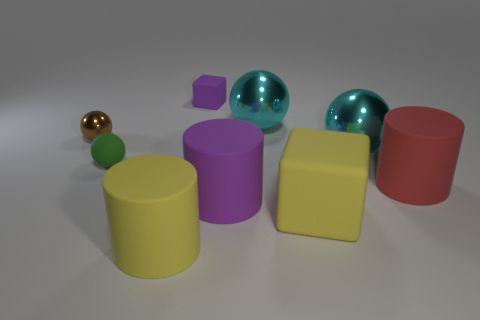Add 1 large blue cubes. How many objects exist? 10 Subtract all balls. How many objects are left? 5 Add 8 tiny green balls. How many tiny green balls are left? 9 Add 9 purple shiny spheres. How many purple shiny spheres exist? 9 Subtract 0 gray cylinders. How many objects are left? 9 Subtract all red cylinders. Subtract all rubber blocks. How many objects are left? 6 